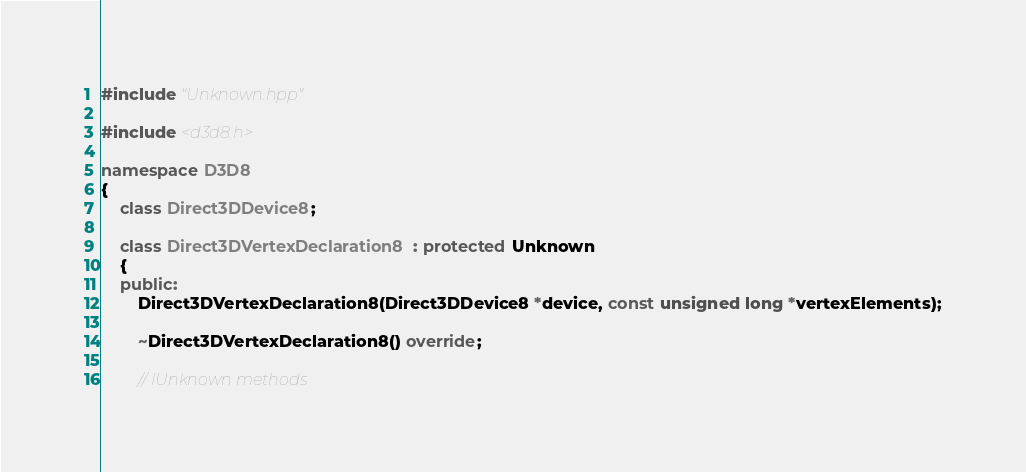<code> <loc_0><loc_0><loc_500><loc_500><_C++_>
#include "Unknown.hpp"

#include <d3d8.h>

namespace D3D8
{
	class Direct3DDevice8;

	class Direct3DVertexDeclaration8 : protected Unknown
	{
	public:
		Direct3DVertexDeclaration8(Direct3DDevice8 *device, const unsigned long *vertexElements);

		~Direct3DVertexDeclaration8() override;

		// IUnknown methods</code> 